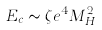<formula> <loc_0><loc_0><loc_500><loc_500>E _ { c } \sim \zeta e ^ { 4 } M _ { H } ^ { 2 }</formula> 